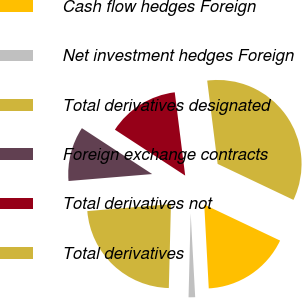Convert chart. <chart><loc_0><loc_0><loc_500><loc_500><pie_chart><fcel>Cash flow hedges Foreign<fcel>Net investment hedges Foreign<fcel>Total derivatives designated<fcel>Foreign exchange contracts<fcel>Total derivatives not<fcel>Total derivatives<nl><fcel>17.09%<fcel>1.26%<fcel>23.28%<fcel>10.53%<fcel>13.81%<fcel>34.04%<nl></chart> 